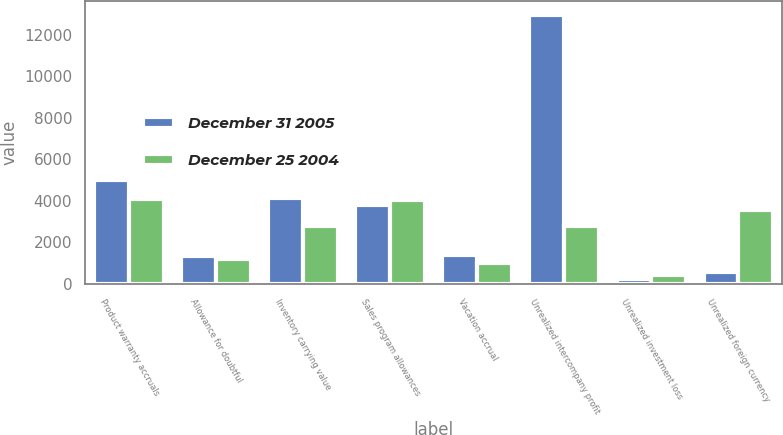Convert chart. <chart><loc_0><loc_0><loc_500><loc_500><stacked_bar_chart><ecel><fcel>Product warranty accruals<fcel>Allowance for doubtful<fcel>Inventory carrying value<fcel>Sales program allowances<fcel>Vacation accrual<fcel>Unrealized intercompany profit<fcel>Unrealized investment loss<fcel>Unrealized foreign currency<nl><fcel>December 31 2005<fcel>5017<fcel>1361<fcel>4120<fcel>3798<fcel>1401<fcel>12978<fcel>219<fcel>550<nl><fcel>December 25 2004<fcel>4084<fcel>1187<fcel>2792<fcel>4035<fcel>1022<fcel>2792<fcel>433<fcel>3579<nl></chart> 